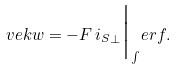<formula> <loc_0><loc_0><loc_500><loc_500>\ v e k { w } = - F \, { i _ { S } } _ { \perp } \Big | _ { \int } e r f .</formula> 